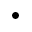Convert formula to latex. <formula><loc_0><loc_0><loc_500><loc_500>\bullet</formula> 